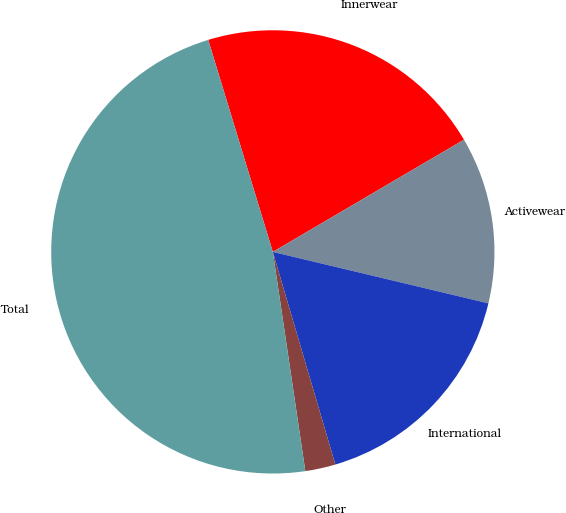Convert chart. <chart><loc_0><loc_0><loc_500><loc_500><pie_chart><fcel>Innerwear<fcel>Activewear<fcel>International<fcel>Other<fcel>Total<nl><fcel>21.26%<fcel>12.18%<fcel>16.72%<fcel>2.21%<fcel>47.64%<nl></chart> 